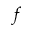Convert formula to latex. <formula><loc_0><loc_0><loc_500><loc_500>f</formula> 